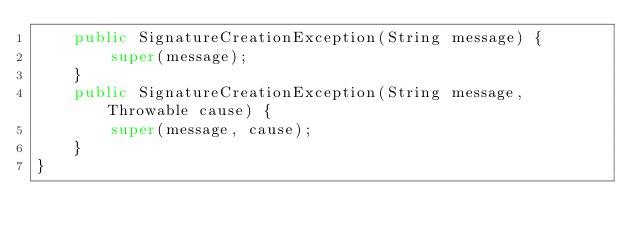<code> <loc_0><loc_0><loc_500><loc_500><_Java_>    public SignatureCreationException(String message) {
        super(message);
    }
    public SignatureCreationException(String message, Throwable cause) {
        super(message, cause);
    }
}
</code> 